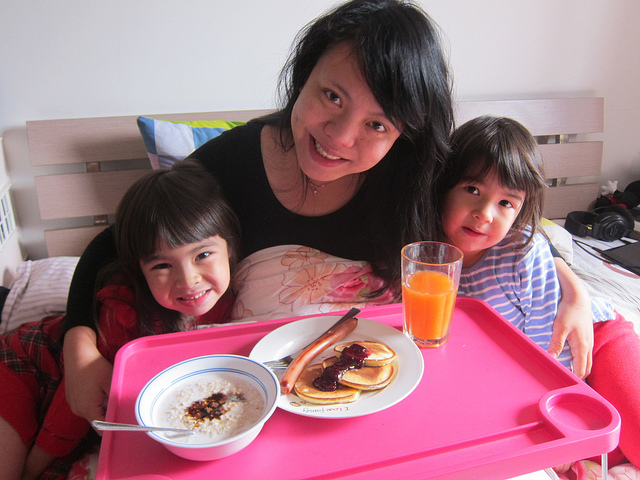What emotions are being expressed by the people in the image? The individuals are displaying joyful expressions with genuine smiles, which suggests a feeling of contentment and happiness. Their relaxed body language and the specifically warm interaction between them also contribute to a sense of warmth and intimacy common within families. 